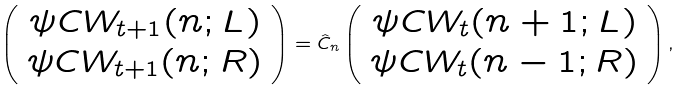Convert formula to latex. <formula><loc_0><loc_0><loc_500><loc_500>\left ( \begin{array} { c } \psi C W _ { t + 1 } ( n ; L ) \\ \psi C W _ { t + 1 } ( n ; R ) \end{array} \right ) = { \hat { C } } _ { n } \left ( \begin{array} { c } \psi C W _ { t } ( n + 1 ; L ) \\ \psi C W _ { t } ( n - 1 ; R ) \end{array} \right ) ,</formula> 